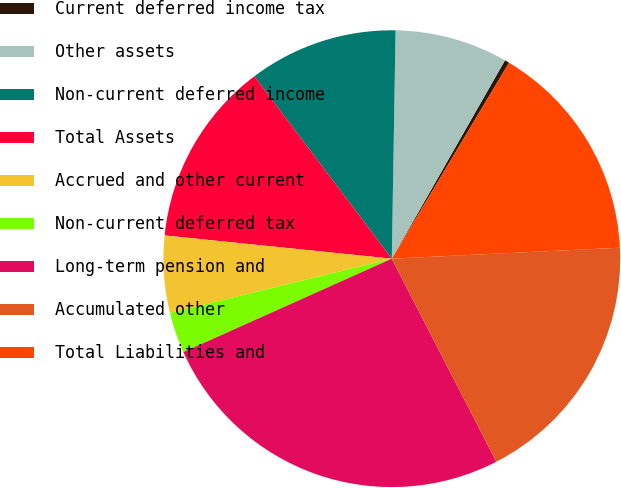<chart> <loc_0><loc_0><loc_500><loc_500><pie_chart><fcel>Current deferred income tax<fcel>Other assets<fcel>Non-current deferred income<fcel>Total Assets<fcel>Accrued and other current<fcel>Non-current deferred tax<fcel>Long-term pension and<fcel>Accumulated other<fcel>Total Liabilities and<nl><fcel>0.33%<fcel>7.99%<fcel>10.54%<fcel>13.1%<fcel>5.44%<fcel>2.89%<fcel>25.86%<fcel>18.2%<fcel>15.65%<nl></chart> 